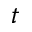<formula> <loc_0><loc_0><loc_500><loc_500>t</formula> 